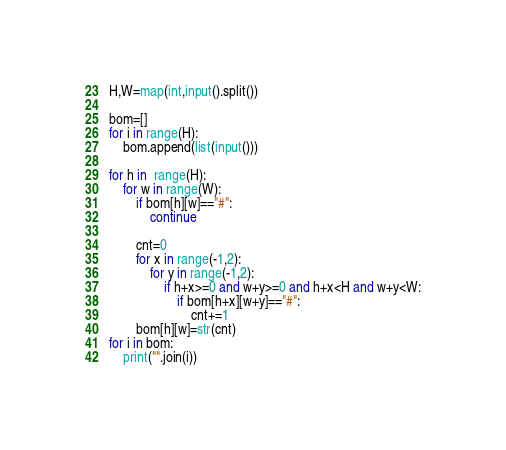<code> <loc_0><loc_0><loc_500><loc_500><_Python_>H,W=map(int,input().split())

bom=[]
for i in range(H):
    bom.append(list(input()))

for h in  range(H):
    for w in range(W):
        if bom[h][w]=="#":
            continue

        cnt=0
        for x in range(-1,2):
            for y in range(-1,2):
                if h+x>=0 and w+y>=0 and h+x<H and w+y<W:
                    if bom[h+x][w+y]=="#":
                        cnt+=1
        bom[h][w]=str(cnt)
for i in bom:
    print("".join(i))
</code> 